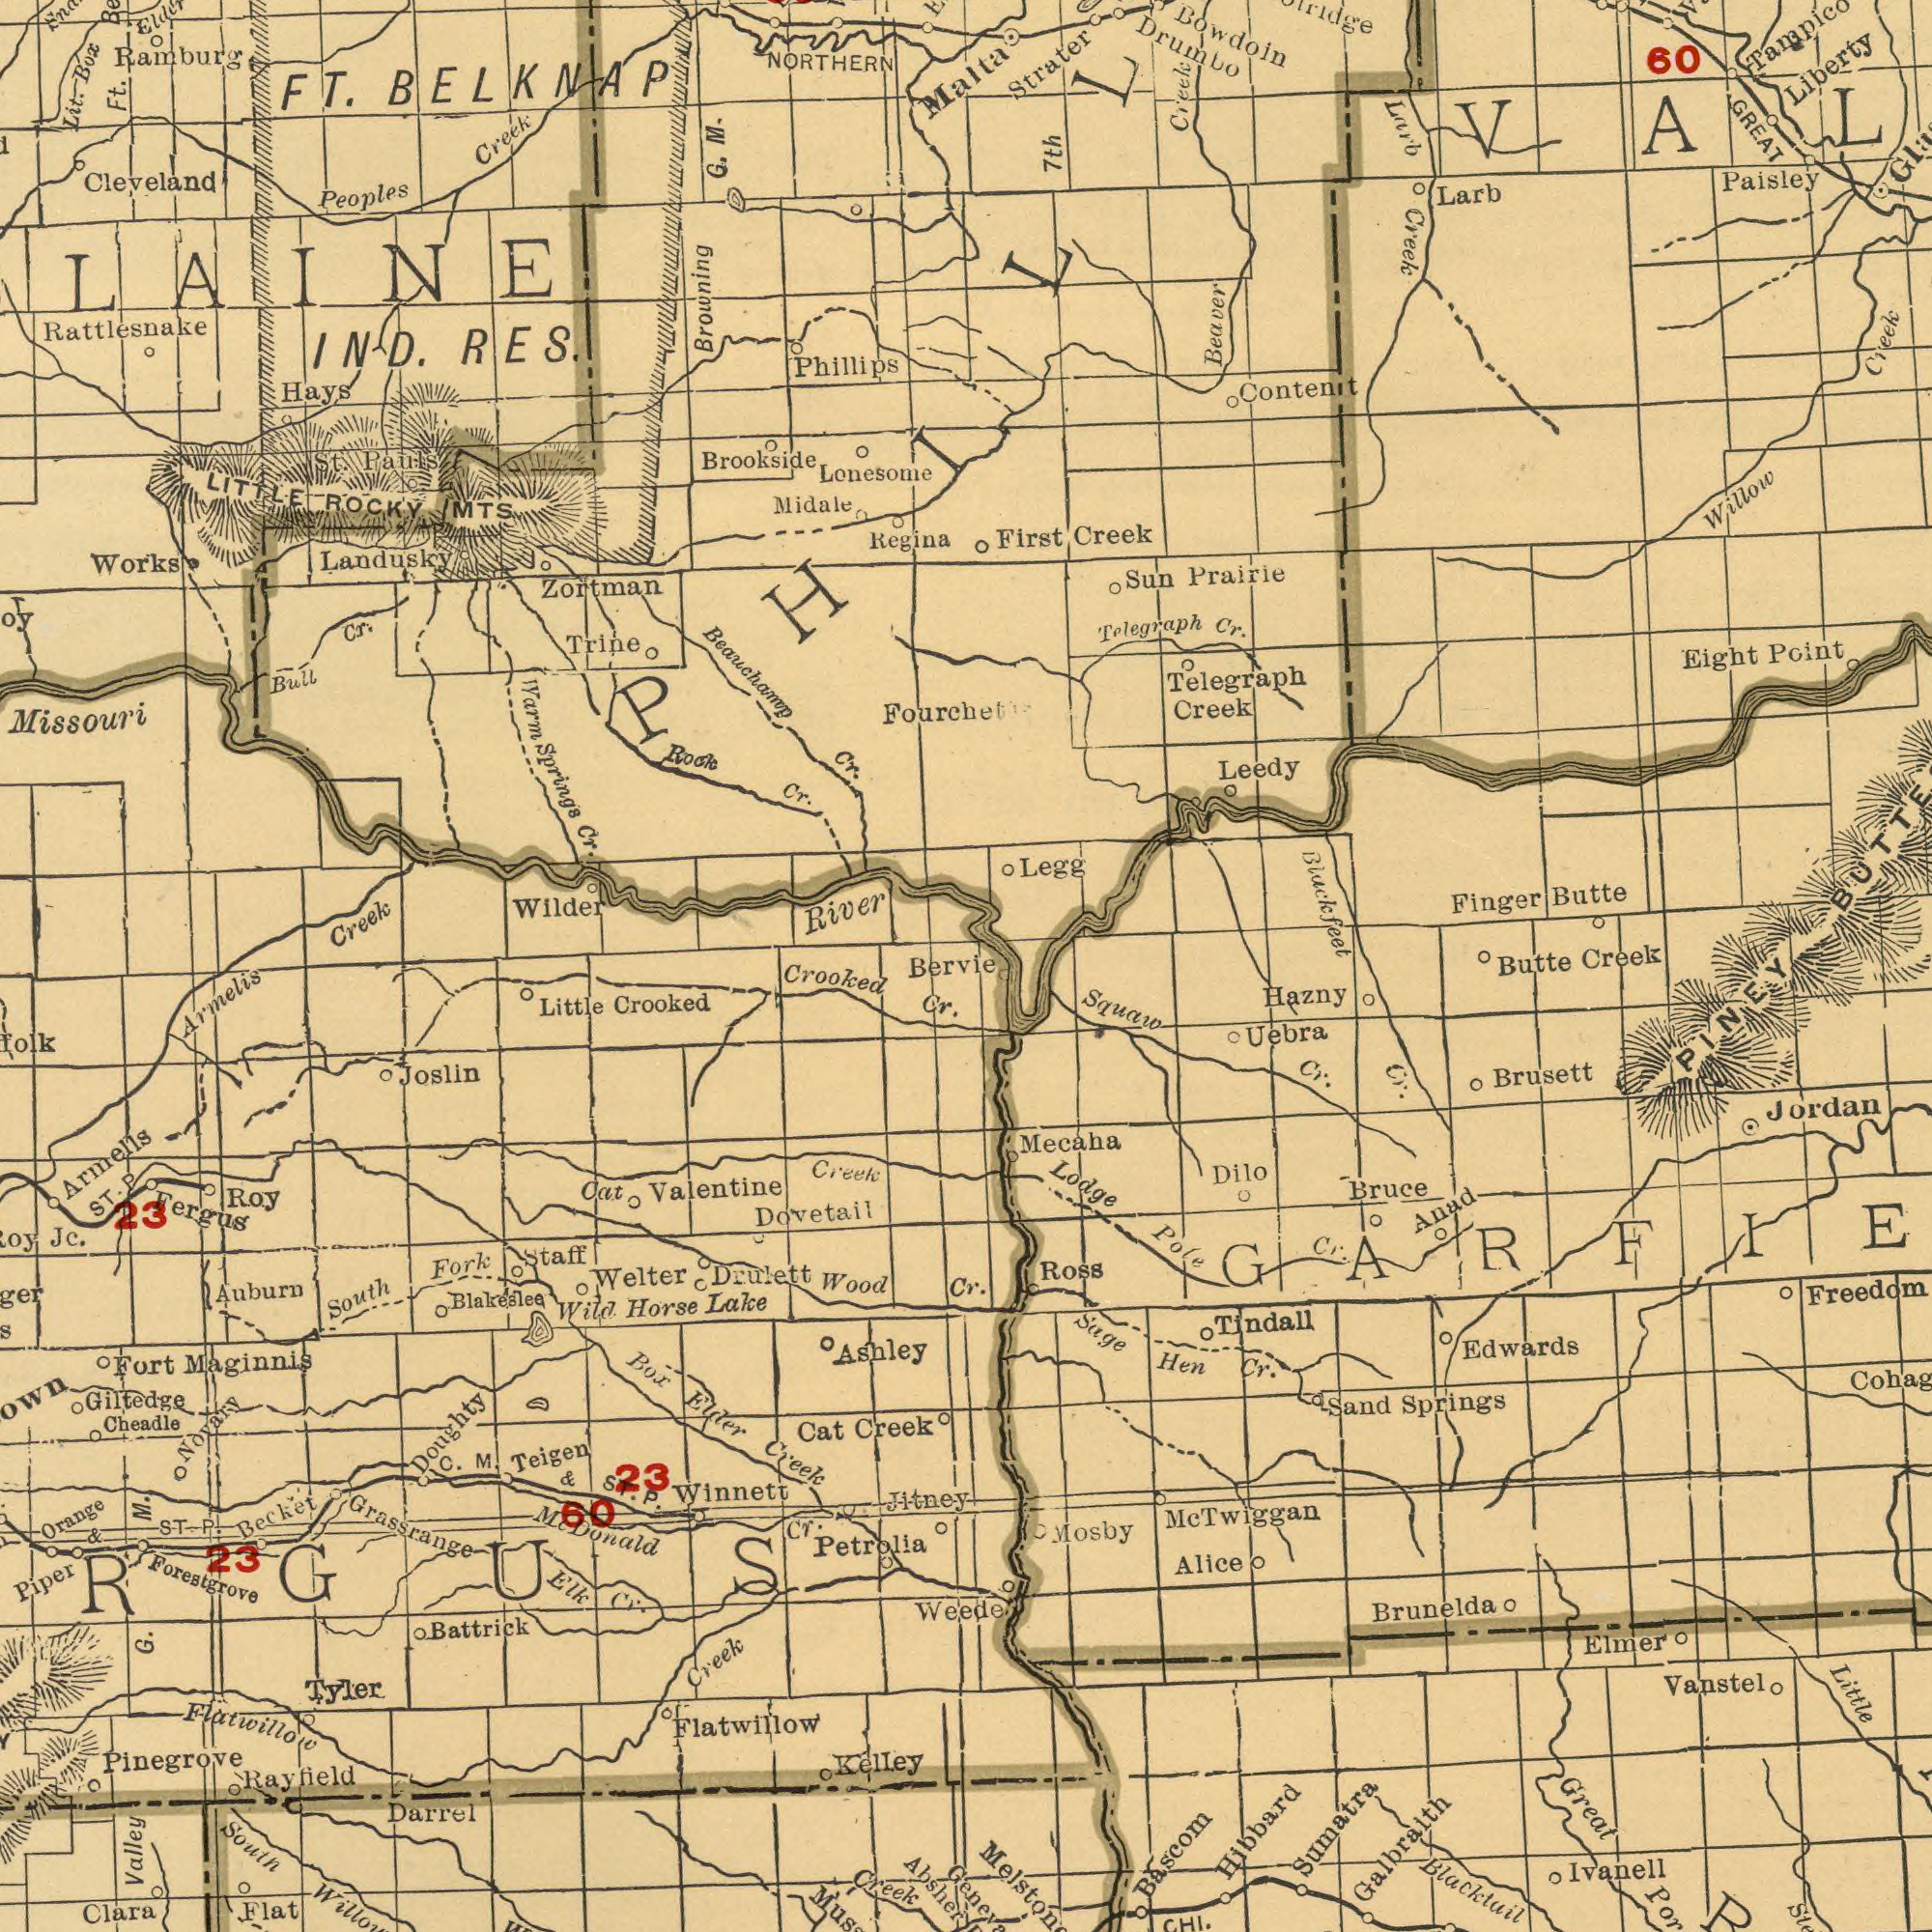What text can you see in the top-left section? Rattlesnake Ramburg Missouri NORTHERN Cleveland Zortman G. Wilder Phillips Lit. Regina Brookside Springs IND. Creek Midale Lonesome LITTLE Box River Trine M. BELKNAP RES. Ft. Works Pauls Rock Creek Cr. Cr. Hays Browning Bull FT. Cr. Peoples Beauchamp ROCKY Cr. Warm MTS St. Landusky LAINE Malta What text appears in the top-right area of the image? Telegraph Telegraph Creek Creek Leedy Content First Paisley Strater Finger Willow Drumbo Prairie Liberty Larb Legg Larb GREAT Cr. Sun 7th Creek Point Creek Bowdoin Creek 60 Beaver Butte Eight Blackfeet creak BUTTE What text is shown in the bottom-left quadrant? Grassrange Flatwillow Forestgrove Crooked Clara Dovetail Drulett Crooked Giltedge Lake Valentine Petrolia Armelis Fergus Flatwillow Creek South Elder Maginnis Piper Creek Creek Box Battrick Ashley Valley Darrel Wild Joslin Flat Becket Elk Auburn Cat Little Roy Jitney Wood Creek Creek Orange Blakeslee South Cheadle Absher 23 Kelley 23 Rayfield C. Cat Jc. Fort Cr. M. M. Novary G. Tyler Welter Armelis Fork Cr. Cr. & Horse Winnett Doughty Staff Pinegrove Bervie ST. P ST. p. Teigen & ST. P. Mc Donald Weede ###RGUS 23 60 What text is visible in the lower-right corner? Cr. Blacktail Hibbard Little Uebra Great Lodge Mecaha Tindall Squaw Brusett Edwards Galbraith Ivanell Brunelda Elmer Alice Anad Vanstel Springs Sage Hen Sumatra Ross Jordan Bascom Dilo Pole Cr. Mosby Sand Bruce Cr. Hazny Cr. Cr. Butte PINEY Mc Twiggan 